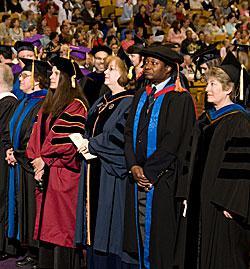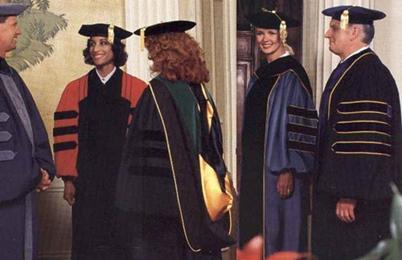The first image is the image on the left, the second image is the image on the right. Examine the images to the left and right. Is the description "At least one person is holding a piece of paper." accurate? Answer yes or no. Yes. The first image is the image on the left, the second image is the image on the right. Considering the images on both sides, is "There are less than six graduates in one of the images." valid? Answer yes or no. Yes. The first image is the image on the left, the second image is the image on the right. Considering the images on both sides, is "There is at least one graduate wearing a green robe in the image on the left" valid? Answer yes or no. No. 